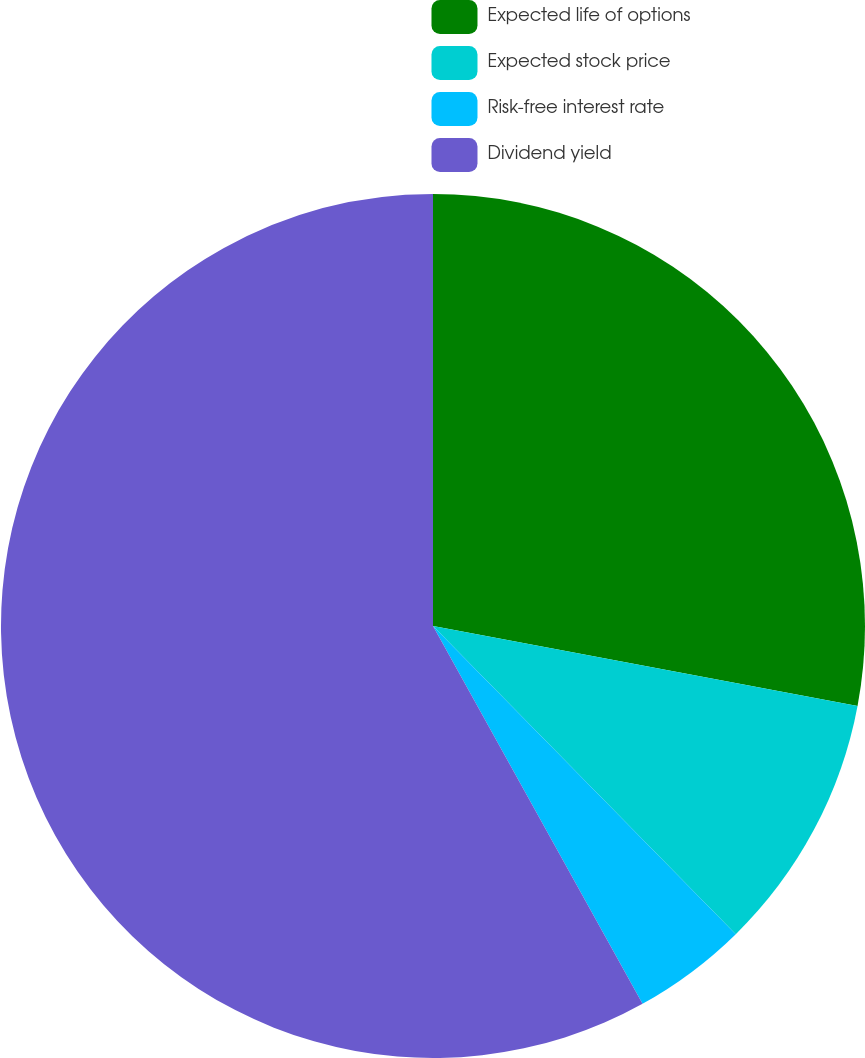Convert chart. <chart><loc_0><loc_0><loc_500><loc_500><pie_chart><fcel>Expected life of options<fcel>Expected stock price<fcel>Risk-free interest rate<fcel>Dividend yield<nl><fcel>27.96%<fcel>9.68%<fcel>4.3%<fcel>58.06%<nl></chart> 